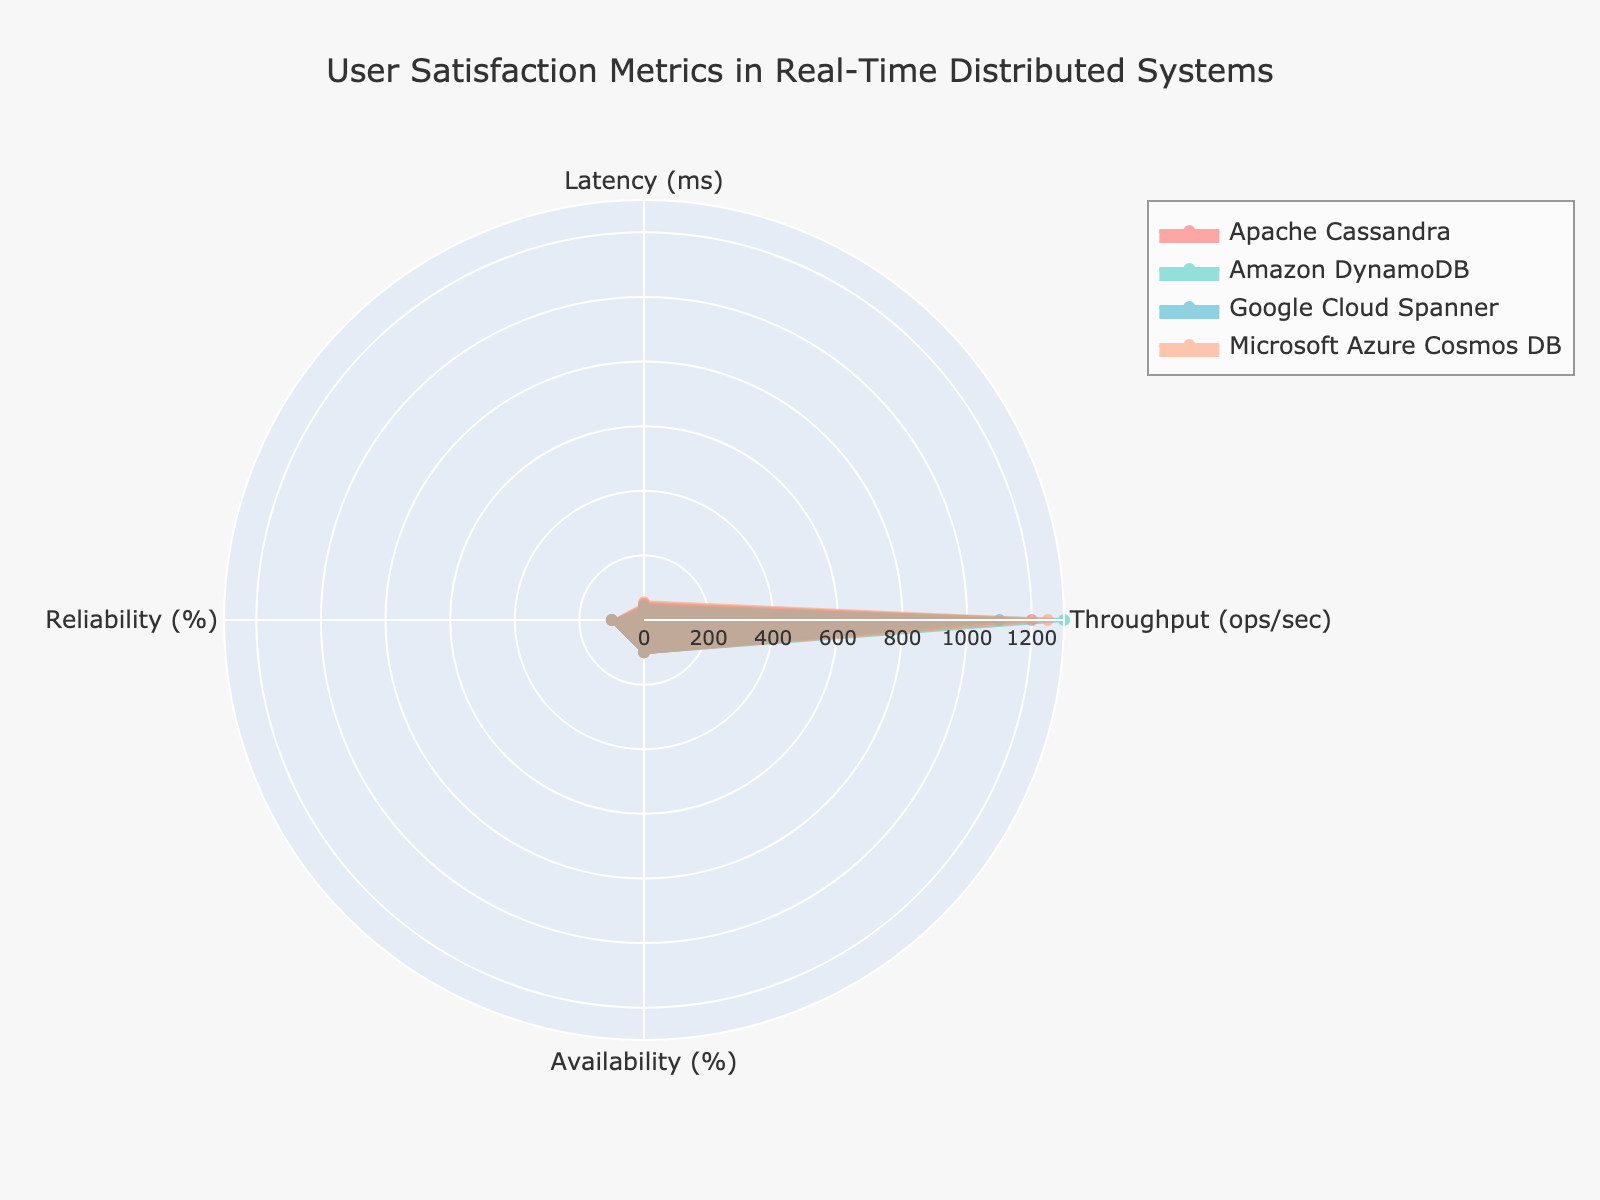What are the categories represented in the radar chart? The categories are the attributes being measured in the radar chart. These are listed in the dataframe under the column names (excluding 'group').
Answer: Latency (ms), Throughput (ops/sec), Availability (%), Reliability (%) Which group has the highest throughput? By examining the throughput (ops/sec) axis on the radar chart, look for the group with the largest value along this axis.
Answer: Amazon DynamoDB How does the availability of Google Cloud Spanner compare to Microsoft Azure Cosmos DB? On the availability axis of the radar chart, identify the values for both Google Cloud Spanner and Microsoft Azure Cosmos DB and compare them.
Answer: Google Cloud Spanner has a slightly higher availability What's the average latency among all groups? Sum the latency values for all groups and divide by the number of groups: (50 + 40 + 45 + 55) / 4.
Answer: 47.5 ms Which group has the lowest reliability percentage? Look at the reliability axis on the radar chart and identify the group with the lowest value.
Answer: Apache Cassandra What's the difference in throughput between Apache Cassandra and Microsoft Azure Cosmos DB? Find the throughput values for both groups and subtract the smaller value from the larger one: 1250 - 1200.
Answer: 50 ops/sec Is the reliability of Amazon DynamoDB greater than that of Google Cloud Spanner? Compare the reliability percentages for both Amazon DynamoDB and Google Cloud Spanner by examining the respective points on the radar chart.
Answer: Yes Rank the groups from highest to lowest in terms of availability. Check the availability percentage for each group and order them from the highest to lowest values.
Answer: Amazon DynamoDB, Google Cloud Spanner, Microsoft Azure Cosmos DB, Apache Cassandra If you considered only the metrics of latency and availability, which group would be considered the best? The best group would have the lowest latency and the highest availability. Compare the latency and availability values simultaneously for each group.
Answer: Amazon DynamoDB Which metric shows the most uniform performance across all groups in the radar chart? Judge this by examining which axis shows the least variance in the lengths of the lines representing each group's performance.
Answer: Latency (ms) 